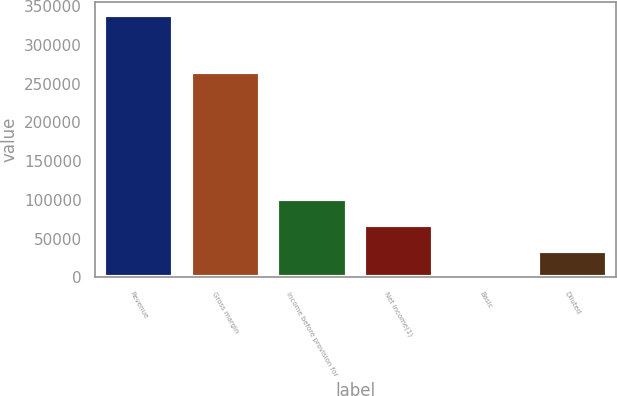Convert chart to OTSL. <chart><loc_0><loc_0><loc_500><loc_500><bar_chart><fcel>Revenue<fcel>Gross margin<fcel>Income before provision for<fcel>Net income(1)<fcel>Basic<fcel>Diluted<nl><fcel>338278<fcel>265106<fcel>101484<fcel>67655.7<fcel>0.13<fcel>33827.9<nl></chart> 